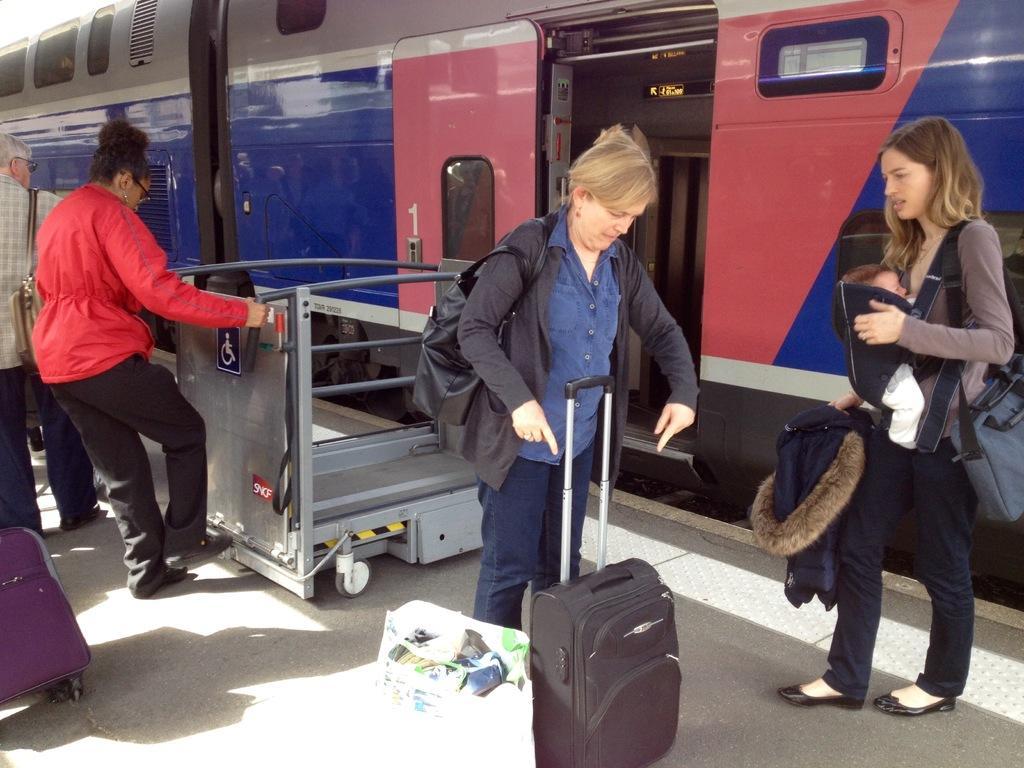In one or two sentences, can you explain what this image depicts? In this picture i could see the train in the background and some persons with the luggage holding in their hand. To the left side a red woman with the jacket is moving a trolley and to right side a lady is holding a baby and a jacket. 